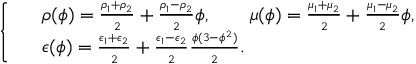<formula> <loc_0><loc_0><loc_500><loc_500>\left \{ \begin{array} { r l } & { \rho ( \phi ) = \frac { \rho _ { 1 } + \rho _ { 2 } } { 2 } + \frac { \rho _ { 1 } - \rho _ { 2 } } { 2 } \phi , \quad \mu ( \phi ) = \frac { \mu _ { 1 } + \mu _ { 2 } } { 2 } + \frac { \mu _ { 1 } - \mu _ { 2 } } { 2 } \phi , } \\ & { \epsilon ( \phi ) = \frac { \epsilon _ { 1 } + \epsilon _ { 2 } } { 2 } + \frac { \epsilon _ { 1 } - \epsilon _ { 2 } } { 2 } \frac { \phi ( 3 - \phi ^ { 2 } ) } { 2 } . } \end{array}</formula> 